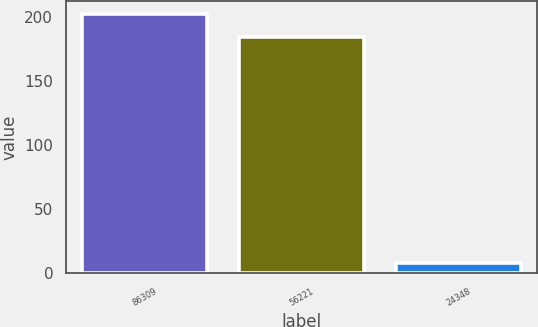Convert chart to OTSL. <chart><loc_0><loc_0><loc_500><loc_500><bar_chart><fcel>86309<fcel>56221<fcel>24348<nl><fcel>202.66<fcel>184.3<fcel>8.4<nl></chart> 